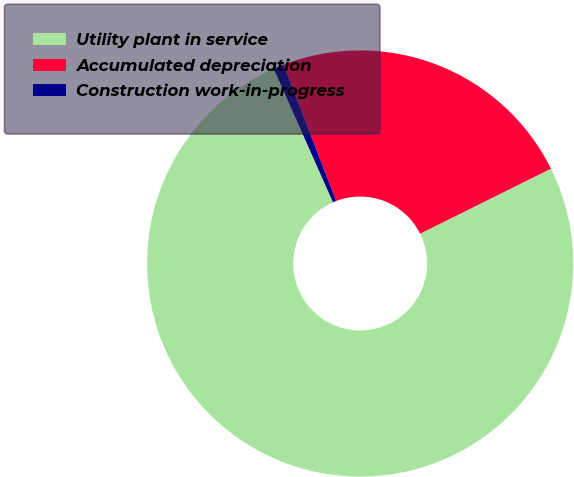Convert chart. <chart><loc_0><loc_0><loc_500><loc_500><pie_chart><fcel>Utility plant in service<fcel>Accumulated depreciation<fcel>Construction work-in-progress<nl><fcel>75.7%<fcel>23.51%<fcel>0.8%<nl></chart> 